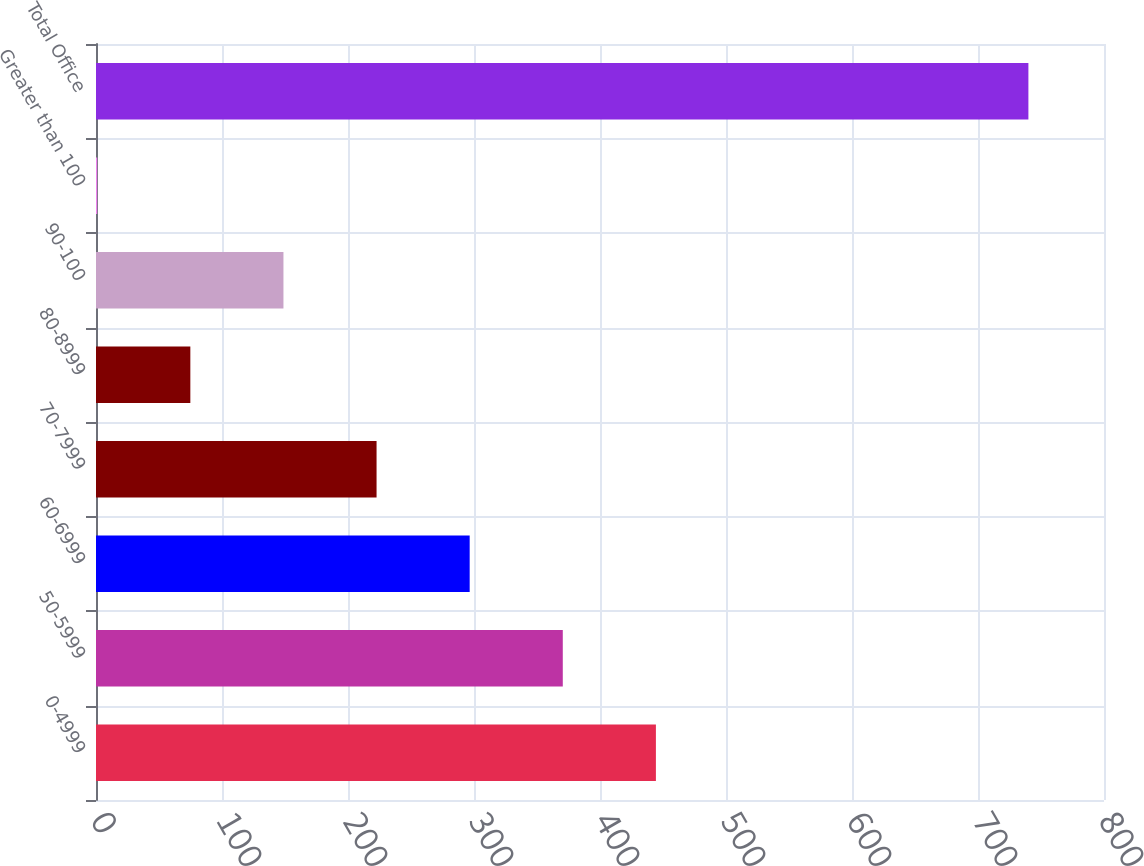Convert chart. <chart><loc_0><loc_0><loc_500><loc_500><bar_chart><fcel>0-4999<fcel>50-5999<fcel>60-6999<fcel>70-7999<fcel>80-8999<fcel>90-100<fcel>Greater than 100<fcel>Total Office<nl><fcel>444.37<fcel>370.47<fcel>296.57<fcel>222.67<fcel>74.87<fcel>148.77<fcel>0.97<fcel>740<nl></chart> 